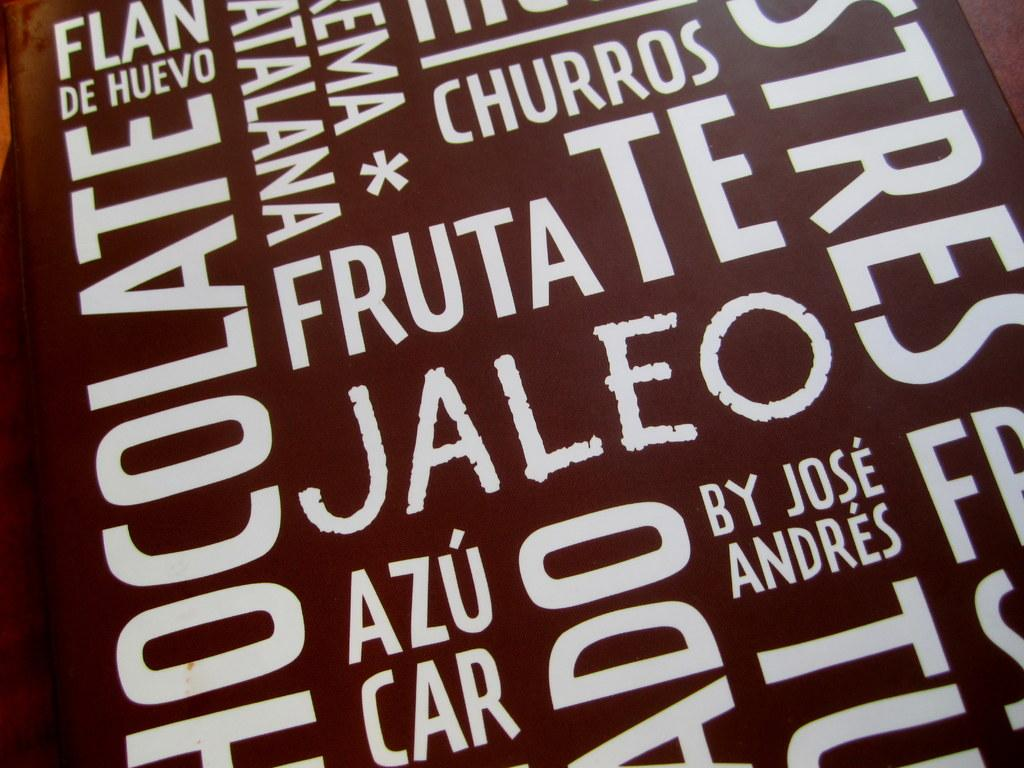<image>
Summarize the visual content of the image. white letters on a brown background including churros by jose andres 